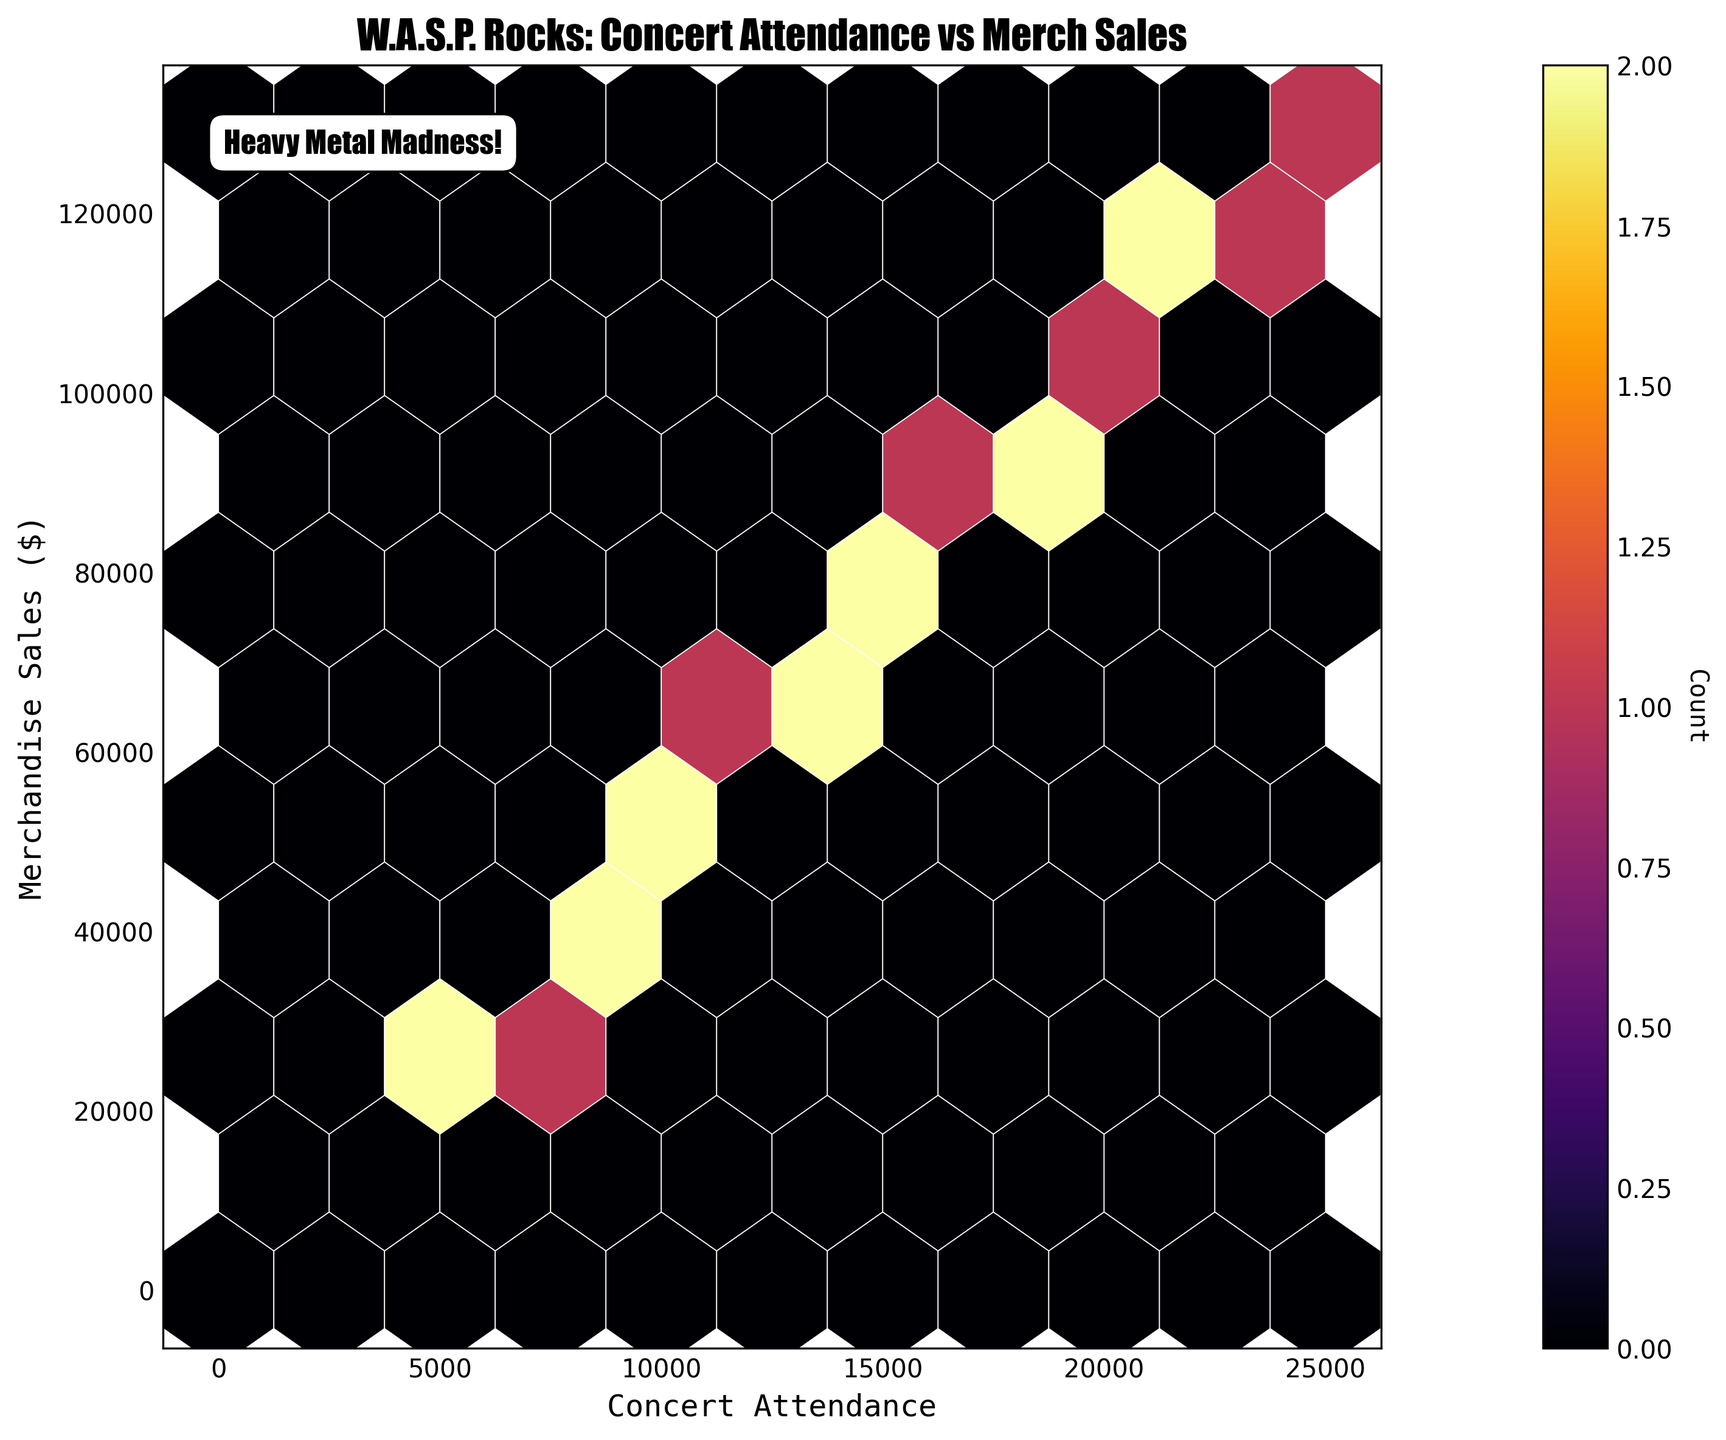What is the title of the figure? The title is typically displayed at the top of the plot and provides a brief summary of the chart's content.
Answer: W.A.S.P. Rocks: Concert Attendance vs Merch Sales What are the labels on the x and y axes? The labels on the axes indicate what each axis represents. The x axis label is at the bottom, and the y axis label is on the left side of the figure.
Answer: Concert Attendance, Merchandise Sales ($) What is the range of the x-axis for concert attendance? The range of the x-axis is determined by the smallest and largest values it covers. This can be seen along the horizontal axis.
Answer: 0 to 25000 What does the color intensity in the hexagons represent? In a hexbin plot, the color intensity typically represents the count or density of points within each bin. This is often explained in the color bar legend next to the plot.
Answer: Count Which hexagon bin appears to have the highest concentration of data points? By examining the hexagon with the darkest (most intense) coloring, we can identify where the highest concentration of data points is located.
Answer: Between 10,000-15,000 attendance and 50,000-80,000 sales How would you describe the relationship between concert attendance and merchandise sales? By observing the overall trend of the hexagon bins, we can deduce if there is a positive, negative, or no correlation between the two variables.
Answer: Positive correlation What is the typical attendance band associated with merchandise sales of around $100,000? Locate the hexagons near the $100,000 mark on the y-axis and observe their corresponding attendance figures on the x-axis.
Answer: 18,000 - 22,000 Is there a noticeable trend in the data? By examining the distribution of hexagons from the bottom left to the top right, we can determine if there is an upward or downward trend, indicating correlation.
Answer: Yes, there is an upward trend What does the text “Heavy Metal Madness!” signify? This text appears to be an additional annotation in the plot, likely serving as a decorative or thematic element. It usually reflects the context or tone of the data.
Answer: A decorative annotation How many data points fall into the hexagon with concert attendance between 7,000 and 9,000? This can be estimated by observing the color intensity and checking it against the color bar indicating the count.
Answer: The specific count would require referring to the color bar legend 